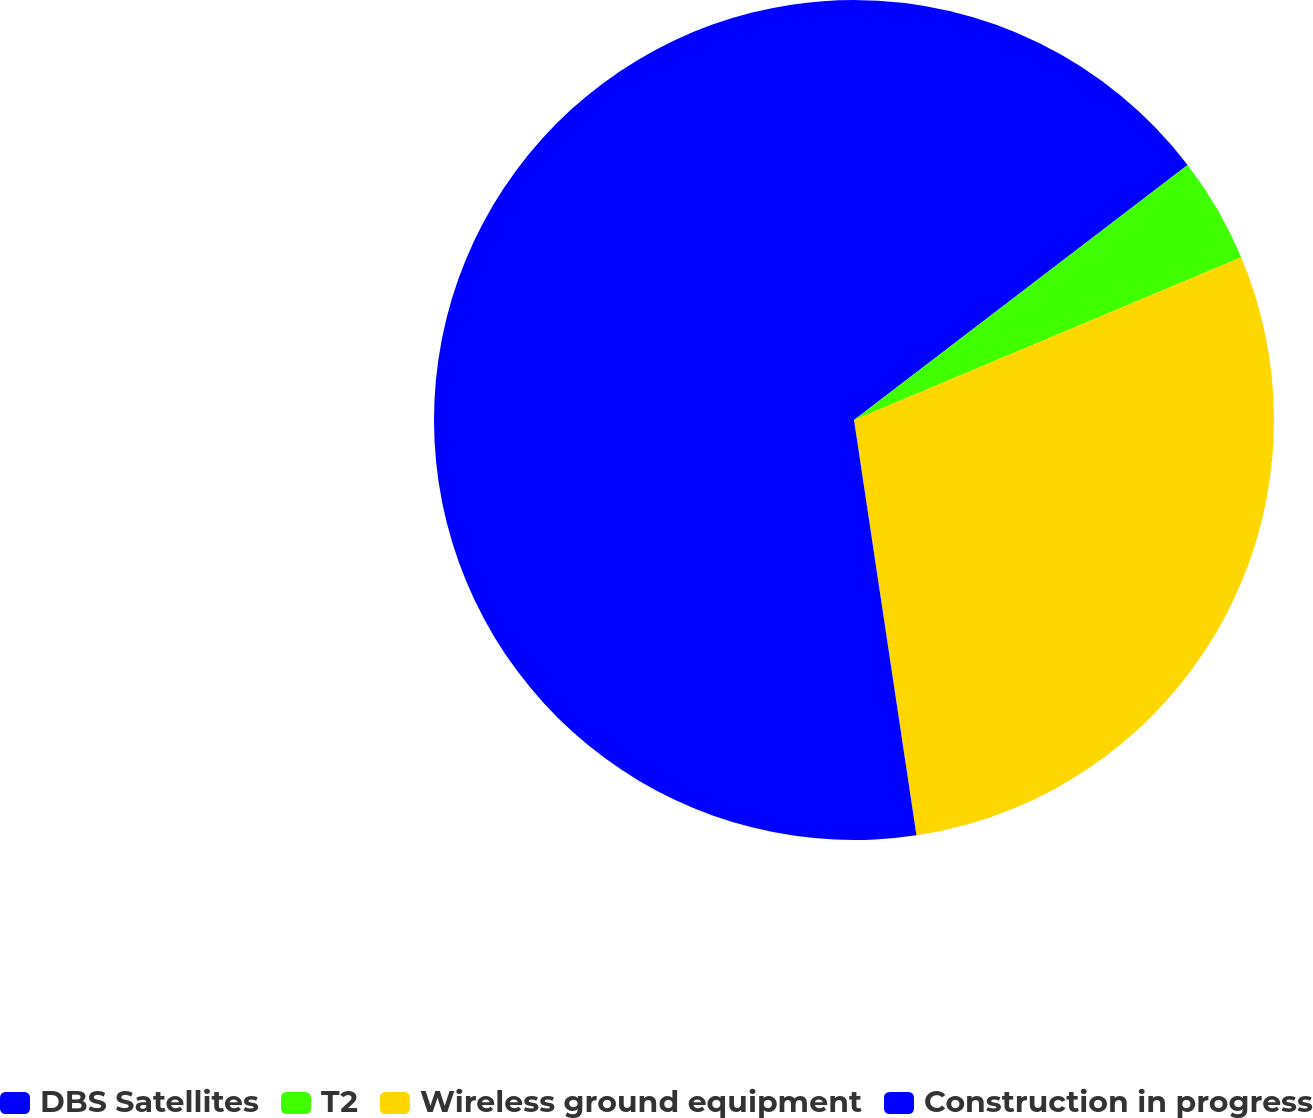Convert chart to OTSL. <chart><loc_0><loc_0><loc_500><loc_500><pie_chart><fcel>DBS Satellites<fcel>T2<fcel>Wireless ground equipment<fcel>Construction in progress<nl><fcel>14.61%<fcel>4.06%<fcel>28.95%<fcel>52.37%<nl></chart> 